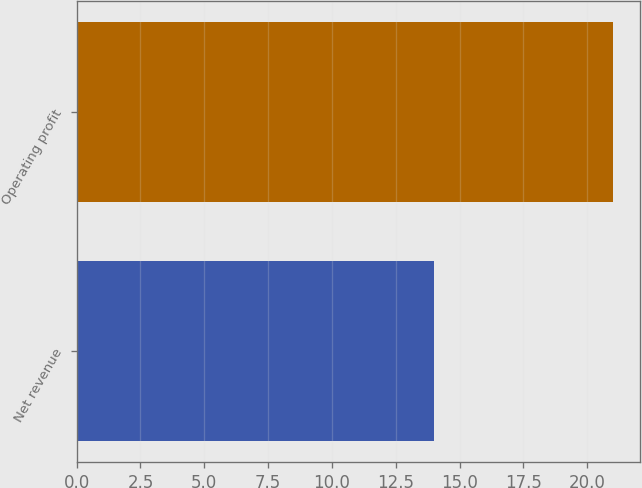Convert chart. <chart><loc_0><loc_0><loc_500><loc_500><bar_chart><fcel>Net revenue<fcel>Operating profit<nl><fcel>14<fcel>21<nl></chart> 